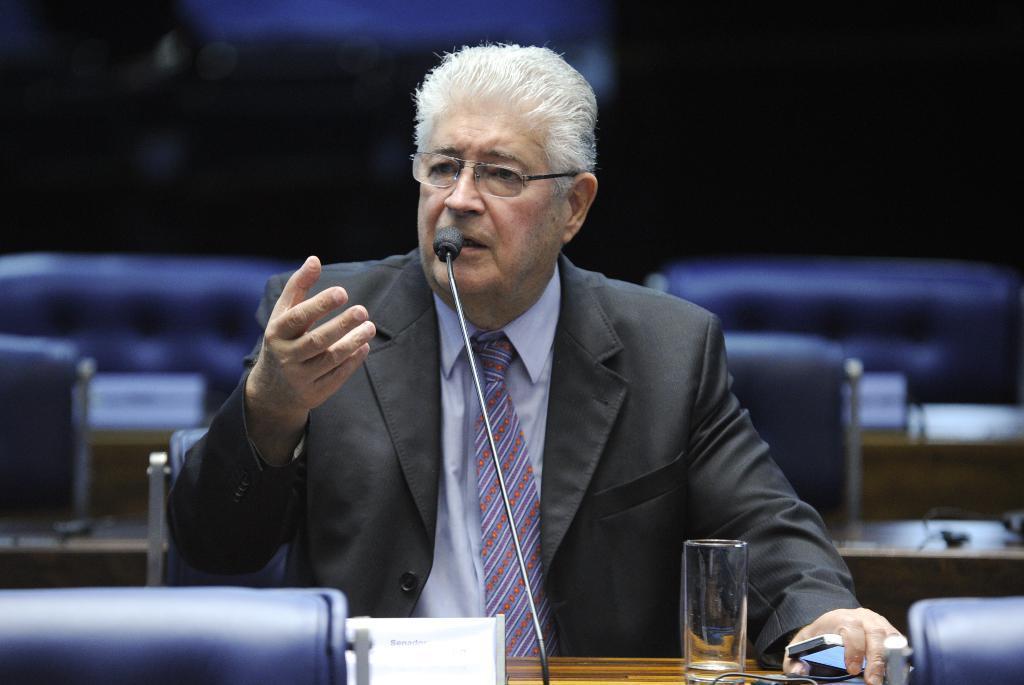Can you describe this image briefly? In this image we can see a person talking, there are some chairs and the tables, on the tables we can see some name boards, water glass, mic and some other objects, in the background it is dark. 